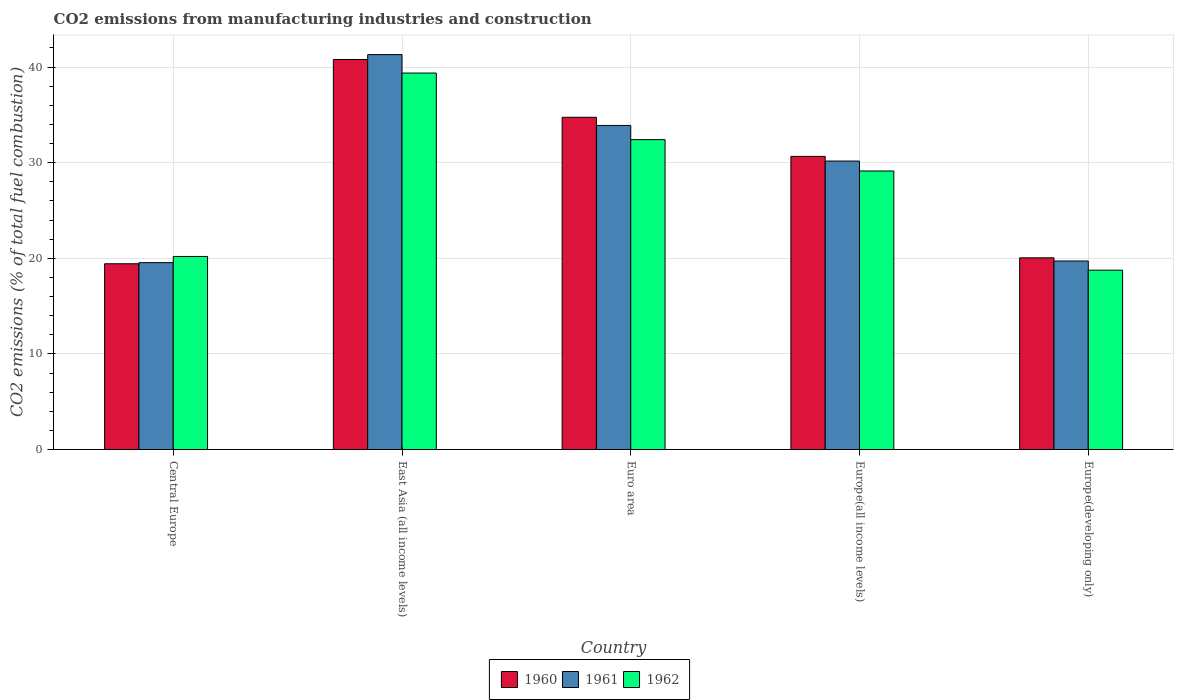Are the number of bars per tick equal to the number of legend labels?
Your response must be concise. Yes. Are the number of bars on each tick of the X-axis equal?
Make the answer very short. Yes. What is the label of the 1st group of bars from the left?
Give a very brief answer. Central Europe. What is the amount of CO2 emitted in 1962 in Europe(developing only)?
Offer a terse response. 18.76. Across all countries, what is the maximum amount of CO2 emitted in 1962?
Ensure brevity in your answer.  39.37. Across all countries, what is the minimum amount of CO2 emitted in 1960?
Keep it short and to the point. 19.43. In which country was the amount of CO2 emitted in 1960 maximum?
Provide a succinct answer. East Asia (all income levels). In which country was the amount of CO2 emitted in 1962 minimum?
Your answer should be very brief. Europe(developing only). What is the total amount of CO2 emitted in 1960 in the graph?
Make the answer very short. 145.67. What is the difference between the amount of CO2 emitted in 1960 in Euro area and that in Europe(all income levels)?
Give a very brief answer. 4.09. What is the difference between the amount of CO2 emitted in 1962 in East Asia (all income levels) and the amount of CO2 emitted in 1961 in Europe(all income levels)?
Offer a very short reply. 9.2. What is the average amount of CO2 emitted in 1962 per country?
Keep it short and to the point. 27.97. What is the difference between the amount of CO2 emitted of/in 1961 and amount of CO2 emitted of/in 1960 in Euro area?
Offer a very short reply. -0.85. In how many countries, is the amount of CO2 emitted in 1962 greater than 18 %?
Provide a short and direct response. 5. What is the ratio of the amount of CO2 emitted in 1961 in Euro area to that in Europe(developing only)?
Give a very brief answer. 1.72. Is the difference between the amount of CO2 emitted in 1961 in East Asia (all income levels) and Euro area greater than the difference between the amount of CO2 emitted in 1960 in East Asia (all income levels) and Euro area?
Make the answer very short. Yes. What is the difference between the highest and the second highest amount of CO2 emitted in 1960?
Offer a very short reply. 6.05. What is the difference between the highest and the lowest amount of CO2 emitted in 1962?
Offer a very short reply. 20.62. What does the 3rd bar from the left in Europe(developing only) represents?
Give a very brief answer. 1962. Is it the case that in every country, the sum of the amount of CO2 emitted in 1962 and amount of CO2 emitted in 1961 is greater than the amount of CO2 emitted in 1960?
Make the answer very short. Yes. Are all the bars in the graph horizontal?
Offer a terse response. No. How many countries are there in the graph?
Your answer should be very brief. 5. What is the difference between two consecutive major ticks on the Y-axis?
Offer a terse response. 10. Does the graph contain grids?
Your response must be concise. Yes. How many legend labels are there?
Make the answer very short. 3. What is the title of the graph?
Make the answer very short. CO2 emissions from manufacturing industries and construction. What is the label or title of the X-axis?
Your answer should be compact. Country. What is the label or title of the Y-axis?
Offer a terse response. CO2 emissions (% of total fuel combustion). What is the CO2 emissions (% of total fuel combustion) of 1960 in Central Europe?
Your response must be concise. 19.43. What is the CO2 emissions (% of total fuel combustion) of 1961 in Central Europe?
Keep it short and to the point. 19.54. What is the CO2 emissions (% of total fuel combustion) of 1962 in Central Europe?
Offer a terse response. 20.19. What is the CO2 emissions (% of total fuel combustion) of 1960 in East Asia (all income levels)?
Your response must be concise. 40.79. What is the CO2 emissions (% of total fuel combustion) in 1961 in East Asia (all income levels)?
Make the answer very short. 41.3. What is the CO2 emissions (% of total fuel combustion) of 1962 in East Asia (all income levels)?
Offer a terse response. 39.37. What is the CO2 emissions (% of total fuel combustion) of 1960 in Euro area?
Your response must be concise. 34.75. What is the CO2 emissions (% of total fuel combustion) of 1961 in Euro area?
Offer a very short reply. 33.89. What is the CO2 emissions (% of total fuel combustion) in 1962 in Euro area?
Ensure brevity in your answer.  32.41. What is the CO2 emissions (% of total fuel combustion) of 1960 in Europe(all income levels)?
Provide a succinct answer. 30.66. What is the CO2 emissions (% of total fuel combustion) of 1961 in Europe(all income levels)?
Give a very brief answer. 30.17. What is the CO2 emissions (% of total fuel combustion) in 1962 in Europe(all income levels)?
Offer a very short reply. 29.13. What is the CO2 emissions (% of total fuel combustion) in 1960 in Europe(developing only)?
Make the answer very short. 20.05. What is the CO2 emissions (% of total fuel combustion) of 1961 in Europe(developing only)?
Give a very brief answer. 19.72. What is the CO2 emissions (% of total fuel combustion) of 1962 in Europe(developing only)?
Provide a short and direct response. 18.76. Across all countries, what is the maximum CO2 emissions (% of total fuel combustion) of 1960?
Ensure brevity in your answer.  40.79. Across all countries, what is the maximum CO2 emissions (% of total fuel combustion) in 1961?
Give a very brief answer. 41.3. Across all countries, what is the maximum CO2 emissions (% of total fuel combustion) of 1962?
Make the answer very short. 39.37. Across all countries, what is the minimum CO2 emissions (% of total fuel combustion) of 1960?
Your response must be concise. 19.43. Across all countries, what is the minimum CO2 emissions (% of total fuel combustion) of 1961?
Make the answer very short. 19.54. Across all countries, what is the minimum CO2 emissions (% of total fuel combustion) in 1962?
Keep it short and to the point. 18.76. What is the total CO2 emissions (% of total fuel combustion) of 1960 in the graph?
Give a very brief answer. 145.67. What is the total CO2 emissions (% of total fuel combustion) of 1961 in the graph?
Keep it short and to the point. 144.62. What is the total CO2 emissions (% of total fuel combustion) in 1962 in the graph?
Ensure brevity in your answer.  139.86. What is the difference between the CO2 emissions (% of total fuel combustion) of 1960 in Central Europe and that in East Asia (all income levels)?
Give a very brief answer. -21.36. What is the difference between the CO2 emissions (% of total fuel combustion) of 1961 in Central Europe and that in East Asia (all income levels)?
Provide a short and direct response. -21.76. What is the difference between the CO2 emissions (% of total fuel combustion) of 1962 in Central Europe and that in East Asia (all income levels)?
Offer a terse response. -19.18. What is the difference between the CO2 emissions (% of total fuel combustion) in 1960 in Central Europe and that in Euro area?
Ensure brevity in your answer.  -15.32. What is the difference between the CO2 emissions (% of total fuel combustion) in 1961 in Central Europe and that in Euro area?
Ensure brevity in your answer.  -14.35. What is the difference between the CO2 emissions (% of total fuel combustion) in 1962 in Central Europe and that in Euro area?
Your answer should be very brief. -12.22. What is the difference between the CO2 emissions (% of total fuel combustion) in 1960 in Central Europe and that in Europe(all income levels)?
Give a very brief answer. -11.23. What is the difference between the CO2 emissions (% of total fuel combustion) of 1961 in Central Europe and that in Europe(all income levels)?
Give a very brief answer. -10.63. What is the difference between the CO2 emissions (% of total fuel combustion) in 1962 in Central Europe and that in Europe(all income levels)?
Ensure brevity in your answer.  -8.94. What is the difference between the CO2 emissions (% of total fuel combustion) in 1960 in Central Europe and that in Europe(developing only)?
Offer a very short reply. -0.62. What is the difference between the CO2 emissions (% of total fuel combustion) of 1961 in Central Europe and that in Europe(developing only)?
Your response must be concise. -0.17. What is the difference between the CO2 emissions (% of total fuel combustion) in 1962 in Central Europe and that in Europe(developing only)?
Your answer should be compact. 1.43. What is the difference between the CO2 emissions (% of total fuel combustion) of 1960 in East Asia (all income levels) and that in Euro area?
Your answer should be compact. 6.05. What is the difference between the CO2 emissions (% of total fuel combustion) in 1961 in East Asia (all income levels) and that in Euro area?
Provide a succinct answer. 7.41. What is the difference between the CO2 emissions (% of total fuel combustion) of 1962 in East Asia (all income levels) and that in Euro area?
Your answer should be compact. 6.96. What is the difference between the CO2 emissions (% of total fuel combustion) in 1960 in East Asia (all income levels) and that in Europe(all income levels)?
Give a very brief answer. 10.13. What is the difference between the CO2 emissions (% of total fuel combustion) of 1961 in East Asia (all income levels) and that in Europe(all income levels)?
Provide a succinct answer. 11.13. What is the difference between the CO2 emissions (% of total fuel combustion) in 1962 in East Asia (all income levels) and that in Europe(all income levels)?
Make the answer very short. 10.25. What is the difference between the CO2 emissions (% of total fuel combustion) in 1960 in East Asia (all income levels) and that in Europe(developing only)?
Offer a very short reply. 20.74. What is the difference between the CO2 emissions (% of total fuel combustion) in 1961 in East Asia (all income levels) and that in Europe(developing only)?
Give a very brief answer. 21.58. What is the difference between the CO2 emissions (% of total fuel combustion) in 1962 in East Asia (all income levels) and that in Europe(developing only)?
Make the answer very short. 20.62. What is the difference between the CO2 emissions (% of total fuel combustion) of 1960 in Euro area and that in Europe(all income levels)?
Provide a succinct answer. 4.09. What is the difference between the CO2 emissions (% of total fuel combustion) of 1961 in Euro area and that in Europe(all income levels)?
Keep it short and to the point. 3.72. What is the difference between the CO2 emissions (% of total fuel combustion) in 1962 in Euro area and that in Europe(all income levels)?
Offer a terse response. 3.28. What is the difference between the CO2 emissions (% of total fuel combustion) of 1960 in Euro area and that in Europe(developing only)?
Ensure brevity in your answer.  14.7. What is the difference between the CO2 emissions (% of total fuel combustion) in 1961 in Euro area and that in Europe(developing only)?
Make the answer very short. 14.18. What is the difference between the CO2 emissions (% of total fuel combustion) in 1962 in Euro area and that in Europe(developing only)?
Your response must be concise. 13.65. What is the difference between the CO2 emissions (% of total fuel combustion) in 1960 in Europe(all income levels) and that in Europe(developing only)?
Keep it short and to the point. 10.61. What is the difference between the CO2 emissions (% of total fuel combustion) of 1961 in Europe(all income levels) and that in Europe(developing only)?
Provide a succinct answer. 10.45. What is the difference between the CO2 emissions (% of total fuel combustion) in 1962 in Europe(all income levels) and that in Europe(developing only)?
Your answer should be very brief. 10.37. What is the difference between the CO2 emissions (% of total fuel combustion) in 1960 in Central Europe and the CO2 emissions (% of total fuel combustion) in 1961 in East Asia (all income levels)?
Ensure brevity in your answer.  -21.87. What is the difference between the CO2 emissions (% of total fuel combustion) of 1960 in Central Europe and the CO2 emissions (% of total fuel combustion) of 1962 in East Asia (all income levels)?
Offer a very short reply. -19.94. What is the difference between the CO2 emissions (% of total fuel combustion) of 1961 in Central Europe and the CO2 emissions (% of total fuel combustion) of 1962 in East Asia (all income levels)?
Offer a very short reply. -19.83. What is the difference between the CO2 emissions (% of total fuel combustion) in 1960 in Central Europe and the CO2 emissions (% of total fuel combustion) in 1961 in Euro area?
Your answer should be very brief. -14.46. What is the difference between the CO2 emissions (% of total fuel combustion) of 1960 in Central Europe and the CO2 emissions (% of total fuel combustion) of 1962 in Euro area?
Keep it short and to the point. -12.98. What is the difference between the CO2 emissions (% of total fuel combustion) in 1961 in Central Europe and the CO2 emissions (% of total fuel combustion) in 1962 in Euro area?
Give a very brief answer. -12.87. What is the difference between the CO2 emissions (% of total fuel combustion) of 1960 in Central Europe and the CO2 emissions (% of total fuel combustion) of 1961 in Europe(all income levels)?
Your response must be concise. -10.74. What is the difference between the CO2 emissions (% of total fuel combustion) of 1960 in Central Europe and the CO2 emissions (% of total fuel combustion) of 1962 in Europe(all income levels)?
Keep it short and to the point. -9.7. What is the difference between the CO2 emissions (% of total fuel combustion) of 1961 in Central Europe and the CO2 emissions (% of total fuel combustion) of 1962 in Europe(all income levels)?
Your response must be concise. -9.58. What is the difference between the CO2 emissions (% of total fuel combustion) of 1960 in Central Europe and the CO2 emissions (% of total fuel combustion) of 1961 in Europe(developing only)?
Your answer should be compact. -0.29. What is the difference between the CO2 emissions (% of total fuel combustion) of 1960 in Central Europe and the CO2 emissions (% of total fuel combustion) of 1962 in Europe(developing only)?
Make the answer very short. 0.67. What is the difference between the CO2 emissions (% of total fuel combustion) of 1961 in Central Europe and the CO2 emissions (% of total fuel combustion) of 1962 in Europe(developing only)?
Ensure brevity in your answer.  0.79. What is the difference between the CO2 emissions (% of total fuel combustion) of 1960 in East Asia (all income levels) and the CO2 emissions (% of total fuel combustion) of 1961 in Euro area?
Your response must be concise. 6.9. What is the difference between the CO2 emissions (% of total fuel combustion) of 1960 in East Asia (all income levels) and the CO2 emissions (% of total fuel combustion) of 1962 in Euro area?
Give a very brief answer. 8.38. What is the difference between the CO2 emissions (% of total fuel combustion) of 1961 in East Asia (all income levels) and the CO2 emissions (% of total fuel combustion) of 1962 in Euro area?
Offer a terse response. 8.89. What is the difference between the CO2 emissions (% of total fuel combustion) in 1960 in East Asia (all income levels) and the CO2 emissions (% of total fuel combustion) in 1961 in Europe(all income levels)?
Keep it short and to the point. 10.62. What is the difference between the CO2 emissions (% of total fuel combustion) of 1960 in East Asia (all income levels) and the CO2 emissions (% of total fuel combustion) of 1962 in Europe(all income levels)?
Provide a succinct answer. 11.66. What is the difference between the CO2 emissions (% of total fuel combustion) in 1961 in East Asia (all income levels) and the CO2 emissions (% of total fuel combustion) in 1962 in Europe(all income levels)?
Your answer should be very brief. 12.17. What is the difference between the CO2 emissions (% of total fuel combustion) in 1960 in East Asia (all income levels) and the CO2 emissions (% of total fuel combustion) in 1961 in Europe(developing only)?
Offer a very short reply. 21.07. What is the difference between the CO2 emissions (% of total fuel combustion) in 1960 in East Asia (all income levels) and the CO2 emissions (% of total fuel combustion) in 1962 in Europe(developing only)?
Offer a terse response. 22.03. What is the difference between the CO2 emissions (% of total fuel combustion) of 1961 in East Asia (all income levels) and the CO2 emissions (% of total fuel combustion) of 1962 in Europe(developing only)?
Make the answer very short. 22.54. What is the difference between the CO2 emissions (% of total fuel combustion) of 1960 in Euro area and the CO2 emissions (% of total fuel combustion) of 1961 in Europe(all income levels)?
Ensure brevity in your answer.  4.58. What is the difference between the CO2 emissions (% of total fuel combustion) of 1960 in Euro area and the CO2 emissions (% of total fuel combustion) of 1962 in Europe(all income levels)?
Provide a short and direct response. 5.62. What is the difference between the CO2 emissions (% of total fuel combustion) of 1961 in Euro area and the CO2 emissions (% of total fuel combustion) of 1962 in Europe(all income levels)?
Offer a terse response. 4.77. What is the difference between the CO2 emissions (% of total fuel combustion) in 1960 in Euro area and the CO2 emissions (% of total fuel combustion) in 1961 in Europe(developing only)?
Make the answer very short. 15.03. What is the difference between the CO2 emissions (% of total fuel combustion) in 1960 in Euro area and the CO2 emissions (% of total fuel combustion) in 1962 in Europe(developing only)?
Offer a very short reply. 15.99. What is the difference between the CO2 emissions (% of total fuel combustion) of 1961 in Euro area and the CO2 emissions (% of total fuel combustion) of 1962 in Europe(developing only)?
Give a very brief answer. 15.14. What is the difference between the CO2 emissions (% of total fuel combustion) of 1960 in Europe(all income levels) and the CO2 emissions (% of total fuel combustion) of 1961 in Europe(developing only)?
Provide a succinct answer. 10.94. What is the difference between the CO2 emissions (% of total fuel combustion) in 1961 in Europe(all income levels) and the CO2 emissions (% of total fuel combustion) in 1962 in Europe(developing only)?
Your answer should be compact. 11.41. What is the average CO2 emissions (% of total fuel combustion) of 1960 per country?
Your response must be concise. 29.13. What is the average CO2 emissions (% of total fuel combustion) in 1961 per country?
Your response must be concise. 28.92. What is the average CO2 emissions (% of total fuel combustion) of 1962 per country?
Your response must be concise. 27.97. What is the difference between the CO2 emissions (% of total fuel combustion) in 1960 and CO2 emissions (% of total fuel combustion) in 1961 in Central Europe?
Offer a terse response. -0.11. What is the difference between the CO2 emissions (% of total fuel combustion) in 1960 and CO2 emissions (% of total fuel combustion) in 1962 in Central Europe?
Provide a succinct answer. -0.76. What is the difference between the CO2 emissions (% of total fuel combustion) of 1961 and CO2 emissions (% of total fuel combustion) of 1962 in Central Europe?
Offer a terse response. -0.65. What is the difference between the CO2 emissions (% of total fuel combustion) of 1960 and CO2 emissions (% of total fuel combustion) of 1961 in East Asia (all income levels)?
Provide a short and direct response. -0.51. What is the difference between the CO2 emissions (% of total fuel combustion) in 1960 and CO2 emissions (% of total fuel combustion) in 1962 in East Asia (all income levels)?
Offer a very short reply. 1.42. What is the difference between the CO2 emissions (% of total fuel combustion) in 1961 and CO2 emissions (% of total fuel combustion) in 1962 in East Asia (all income levels)?
Keep it short and to the point. 1.93. What is the difference between the CO2 emissions (% of total fuel combustion) of 1960 and CO2 emissions (% of total fuel combustion) of 1961 in Euro area?
Your answer should be compact. 0.85. What is the difference between the CO2 emissions (% of total fuel combustion) in 1960 and CO2 emissions (% of total fuel combustion) in 1962 in Euro area?
Keep it short and to the point. 2.34. What is the difference between the CO2 emissions (% of total fuel combustion) of 1961 and CO2 emissions (% of total fuel combustion) of 1962 in Euro area?
Offer a very short reply. 1.48. What is the difference between the CO2 emissions (% of total fuel combustion) in 1960 and CO2 emissions (% of total fuel combustion) in 1961 in Europe(all income levels)?
Offer a terse response. 0.49. What is the difference between the CO2 emissions (% of total fuel combustion) in 1960 and CO2 emissions (% of total fuel combustion) in 1962 in Europe(all income levels)?
Your answer should be very brief. 1.53. What is the difference between the CO2 emissions (% of total fuel combustion) in 1961 and CO2 emissions (% of total fuel combustion) in 1962 in Europe(all income levels)?
Offer a very short reply. 1.04. What is the difference between the CO2 emissions (% of total fuel combustion) in 1960 and CO2 emissions (% of total fuel combustion) in 1961 in Europe(developing only)?
Provide a succinct answer. 0.33. What is the difference between the CO2 emissions (% of total fuel combustion) of 1960 and CO2 emissions (% of total fuel combustion) of 1962 in Europe(developing only)?
Offer a terse response. 1.29. What is the difference between the CO2 emissions (% of total fuel combustion) of 1961 and CO2 emissions (% of total fuel combustion) of 1962 in Europe(developing only)?
Offer a very short reply. 0.96. What is the ratio of the CO2 emissions (% of total fuel combustion) in 1960 in Central Europe to that in East Asia (all income levels)?
Ensure brevity in your answer.  0.48. What is the ratio of the CO2 emissions (% of total fuel combustion) in 1961 in Central Europe to that in East Asia (all income levels)?
Ensure brevity in your answer.  0.47. What is the ratio of the CO2 emissions (% of total fuel combustion) in 1962 in Central Europe to that in East Asia (all income levels)?
Offer a terse response. 0.51. What is the ratio of the CO2 emissions (% of total fuel combustion) in 1960 in Central Europe to that in Euro area?
Provide a short and direct response. 0.56. What is the ratio of the CO2 emissions (% of total fuel combustion) of 1961 in Central Europe to that in Euro area?
Provide a short and direct response. 0.58. What is the ratio of the CO2 emissions (% of total fuel combustion) in 1962 in Central Europe to that in Euro area?
Provide a succinct answer. 0.62. What is the ratio of the CO2 emissions (% of total fuel combustion) in 1960 in Central Europe to that in Europe(all income levels)?
Provide a short and direct response. 0.63. What is the ratio of the CO2 emissions (% of total fuel combustion) of 1961 in Central Europe to that in Europe(all income levels)?
Keep it short and to the point. 0.65. What is the ratio of the CO2 emissions (% of total fuel combustion) of 1962 in Central Europe to that in Europe(all income levels)?
Offer a terse response. 0.69. What is the ratio of the CO2 emissions (% of total fuel combustion) in 1960 in Central Europe to that in Europe(developing only)?
Offer a very short reply. 0.97. What is the ratio of the CO2 emissions (% of total fuel combustion) of 1961 in Central Europe to that in Europe(developing only)?
Your response must be concise. 0.99. What is the ratio of the CO2 emissions (% of total fuel combustion) in 1962 in Central Europe to that in Europe(developing only)?
Offer a terse response. 1.08. What is the ratio of the CO2 emissions (% of total fuel combustion) in 1960 in East Asia (all income levels) to that in Euro area?
Your answer should be very brief. 1.17. What is the ratio of the CO2 emissions (% of total fuel combustion) of 1961 in East Asia (all income levels) to that in Euro area?
Offer a terse response. 1.22. What is the ratio of the CO2 emissions (% of total fuel combustion) in 1962 in East Asia (all income levels) to that in Euro area?
Provide a succinct answer. 1.21. What is the ratio of the CO2 emissions (% of total fuel combustion) of 1960 in East Asia (all income levels) to that in Europe(all income levels)?
Offer a very short reply. 1.33. What is the ratio of the CO2 emissions (% of total fuel combustion) of 1961 in East Asia (all income levels) to that in Europe(all income levels)?
Provide a succinct answer. 1.37. What is the ratio of the CO2 emissions (% of total fuel combustion) in 1962 in East Asia (all income levels) to that in Europe(all income levels)?
Ensure brevity in your answer.  1.35. What is the ratio of the CO2 emissions (% of total fuel combustion) of 1960 in East Asia (all income levels) to that in Europe(developing only)?
Offer a very short reply. 2.03. What is the ratio of the CO2 emissions (% of total fuel combustion) in 1961 in East Asia (all income levels) to that in Europe(developing only)?
Offer a terse response. 2.09. What is the ratio of the CO2 emissions (% of total fuel combustion) of 1962 in East Asia (all income levels) to that in Europe(developing only)?
Offer a terse response. 2.1. What is the ratio of the CO2 emissions (% of total fuel combustion) in 1960 in Euro area to that in Europe(all income levels)?
Offer a very short reply. 1.13. What is the ratio of the CO2 emissions (% of total fuel combustion) of 1961 in Euro area to that in Europe(all income levels)?
Ensure brevity in your answer.  1.12. What is the ratio of the CO2 emissions (% of total fuel combustion) in 1962 in Euro area to that in Europe(all income levels)?
Your response must be concise. 1.11. What is the ratio of the CO2 emissions (% of total fuel combustion) in 1960 in Euro area to that in Europe(developing only)?
Offer a very short reply. 1.73. What is the ratio of the CO2 emissions (% of total fuel combustion) in 1961 in Euro area to that in Europe(developing only)?
Make the answer very short. 1.72. What is the ratio of the CO2 emissions (% of total fuel combustion) in 1962 in Euro area to that in Europe(developing only)?
Provide a short and direct response. 1.73. What is the ratio of the CO2 emissions (% of total fuel combustion) in 1960 in Europe(all income levels) to that in Europe(developing only)?
Offer a terse response. 1.53. What is the ratio of the CO2 emissions (% of total fuel combustion) in 1961 in Europe(all income levels) to that in Europe(developing only)?
Offer a very short reply. 1.53. What is the ratio of the CO2 emissions (% of total fuel combustion) of 1962 in Europe(all income levels) to that in Europe(developing only)?
Offer a terse response. 1.55. What is the difference between the highest and the second highest CO2 emissions (% of total fuel combustion) of 1960?
Your answer should be compact. 6.05. What is the difference between the highest and the second highest CO2 emissions (% of total fuel combustion) in 1961?
Ensure brevity in your answer.  7.41. What is the difference between the highest and the second highest CO2 emissions (% of total fuel combustion) of 1962?
Offer a very short reply. 6.96. What is the difference between the highest and the lowest CO2 emissions (% of total fuel combustion) of 1960?
Keep it short and to the point. 21.36. What is the difference between the highest and the lowest CO2 emissions (% of total fuel combustion) in 1961?
Your answer should be compact. 21.76. What is the difference between the highest and the lowest CO2 emissions (% of total fuel combustion) of 1962?
Your response must be concise. 20.62. 